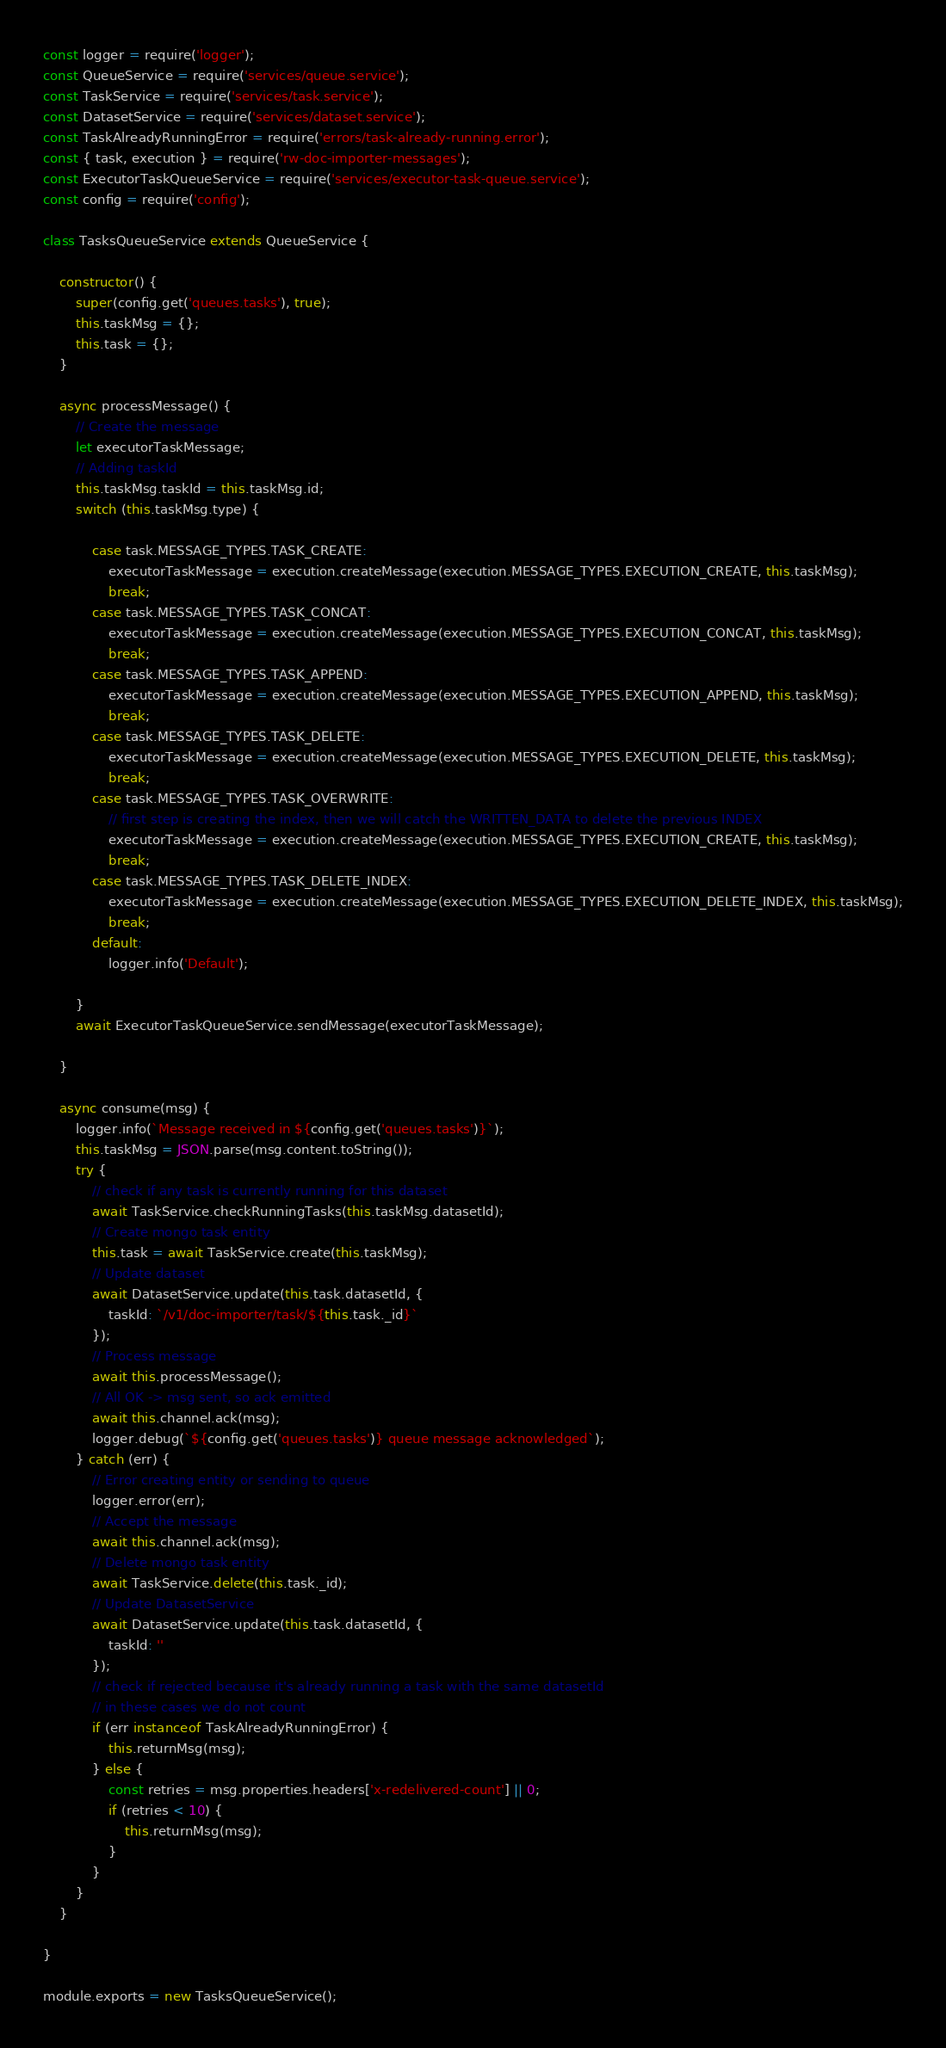<code> <loc_0><loc_0><loc_500><loc_500><_JavaScript_>const logger = require('logger');
const QueueService = require('services/queue.service');
const TaskService = require('services/task.service');
const DatasetService = require('services/dataset.service');
const TaskAlreadyRunningError = require('errors/task-already-running.error');
const { task, execution } = require('rw-doc-importer-messages');
const ExecutorTaskQueueService = require('services/executor-task-queue.service');
const config = require('config');

class TasksQueueService extends QueueService {

    constructor() {
        super(config.get('queues.tasks'), true);
        this.taskMsg = {};
        this.task = {};
    }

    async processMessage() {
        // Create the message
        let executorTaskMessage;
        // Adding taskId
        this.taskMsg.taskId = this.taskMsg.id;
        switch (this.taskMsg.type) {

            case task.MESSAGE_TYPES.TASK_CREATE:
                executorTaskMessage = execution.createMessage(execution.MESSAGE_TYPES.EXECUTION_CREATE, this.taskMsg);
                break;
            case task.MESSAGE_TYPES.TASK_CONCAT:
                executorTaskMessage = execution.createMessage(execution.MESSAGE_TYPES.EXECUTION_CONCAT, this.taskMsg);
                break;
            case task.MESSAGE_TYPES.TASK_APPEND:
                executorTaskMessage = execution.createMessage(execution.MESSAGE_TYPES.EXECUTION_APPEND, this.taskMsg);
                break;
            case task.MESSAGE_TYPES.TASK_DELETE:
                executorTaskMessage = execution.createMessage(execution.MESSAGE_TYPES.EXECUTION_DELETE, this.taskMsg);
                break;
            case task.MESSAGE_TYPES.TASK_OVERWRITE:
                // first step is creating the index, then we will catch the WRITTEN_DATA to delete the previous INDEX
                executorTaskMessage = execution.createMessage(execution.MESSAGE_TYPES.EXECUTION_CREATE, this.taskMsg);
                break;
            case task.MESSAGE_TYPES.TASK_DELETE_INDEX:
                executorTaskMessage = execution.createMessage(execution.MESSAGE_TYPES.EXECUTION_DELETE_INDEX, this.taskMsg);
                break;
            default:
                logger.info('Default');

        }
        await ExecutorTaskQueueService.sendMessage(executorTaskMessage);

    }

    async consume(msg) {
        logger.info(`Message received in ${config.get('queues.tasks')}`);
        this.taskMsg = JSON.parse(msg.content.toString());
        try {
            // check if any task is currently running for this dataset
            await TaskService.checkRunningTasks(this.taskMsg.datasetId);
            // Create mongo task entity
            this.task = await TaskService.create(this.taskMsg);
            // Update dataset
            await DatasetService.update(this.task.datasetId, {
                taskId: `/v1/doc-importer/task/${this.task._id}`
            });
            // Process message
            await this.processMessage();
            // All OK -> msg sent, so ack emitted
            await this.channel.ack(msg);
            logger.debug(`${config.get('queues.tasks')} queue message acknowledged`);
        } catch (err) {
            // Error creating entity or sending to queue
            logger.error(err);
            // Accept the message
            await this.channel.ack(msg);
            // Delete mongo task entity
            await TaskService.delete(this.task._id);
            // Update DatasetService
            await DatasetService.update(this.task.datasetId, {
                taskId: ''
            });
            // check if rejected because it's already running a task with the same datasetId
            // in these cases we do not count
            if (err instanceof TaskAlreadyRunningError) {
                this.returnMsg(msg);
            } else {
                const retries = msg.properties.headers['x-redelivered-count'] || 0;
                if (retries < 10) {
                    this.returnMsg(msg);
                }
            }
        }
    }

}

module.exports = new TasksQueueService();
</code> 